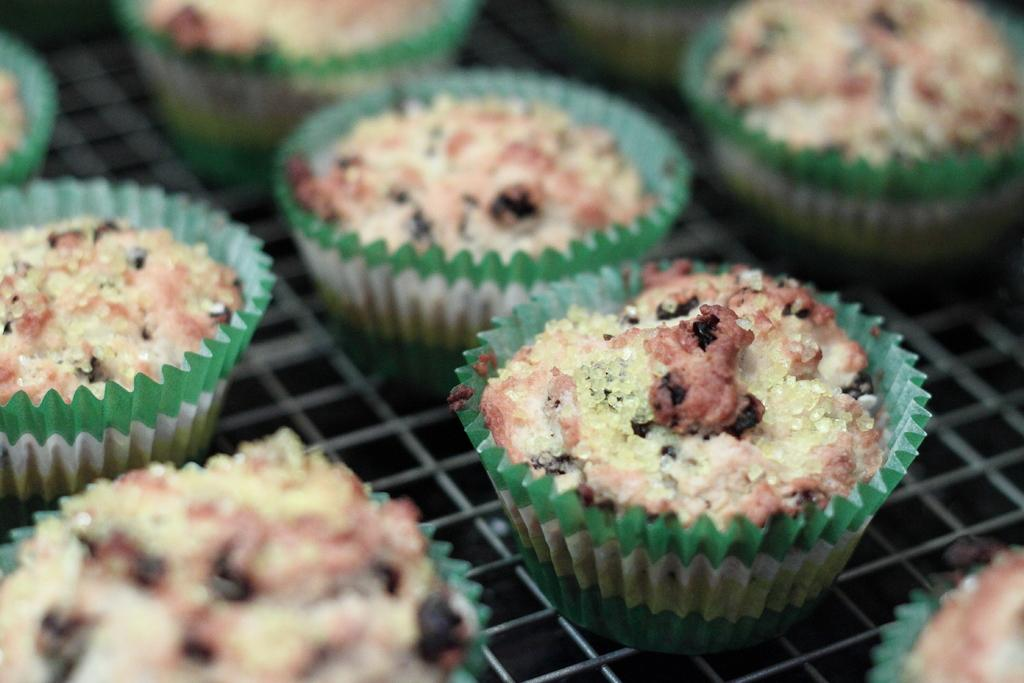What type of food can be seen in the picture? There are cupcakes in the picture. What is the cupcakes placed on? The cupcakes are placed on an object, but the specific object is not mentioned in the facts. What type of debt is being discussed by the minister in the image? There is no minister or discussion of debt present in the image; it only features cupcakes. Where is the oven located in the image? There is no oven present in the image; it only features cupcakes. 